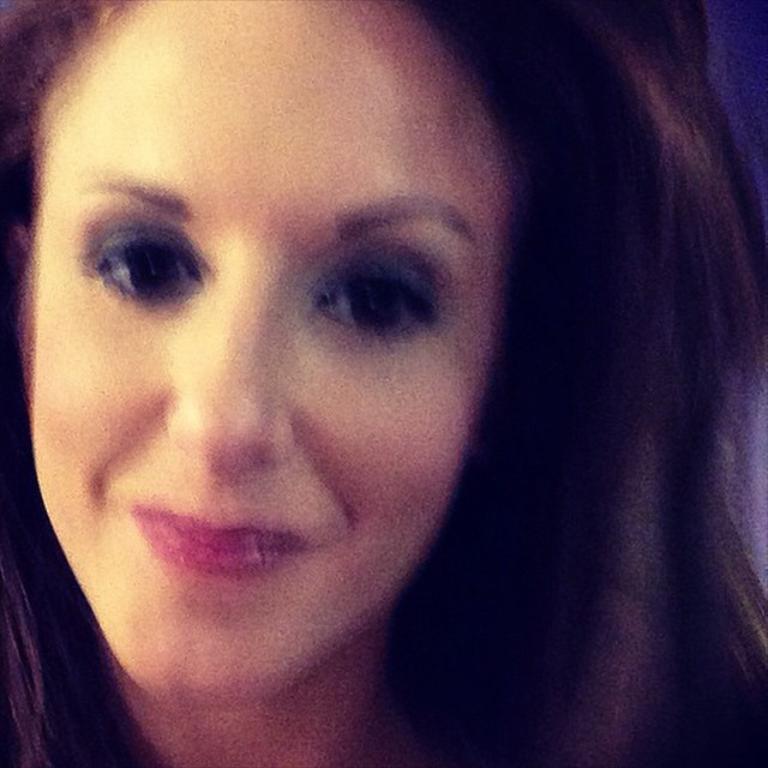Describe this image in one or two sentences. In the foreground of the image there is a woman. 